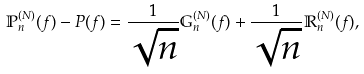Convert formula to latex. <formula><loc_0><loc_0><loc_500><loc_500>\mathbb { P } _ { n } ^ { ( N ) } ( f ) - P ( f ) = \frac { 1 } { \sqrt { n } } \mathbb { G } _ { n } ^ { ( N ) } ( f ) + \frac { 1 } { \sqrt { n } } \mathbb { R } _ { n } ^ { ( N ) } ( f ) ,</formula> 